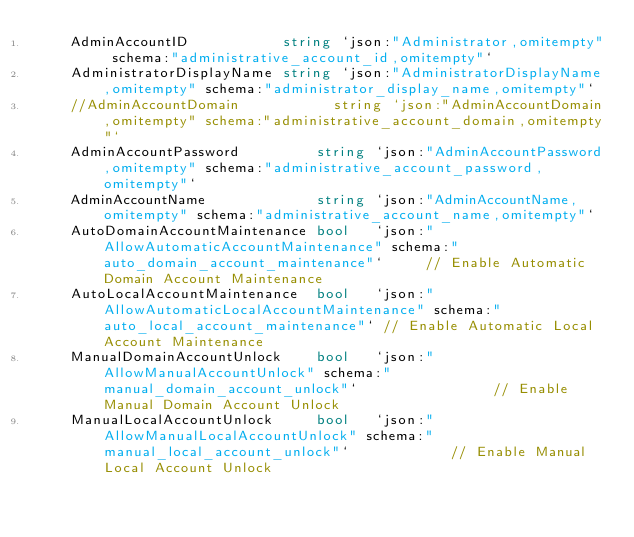Convert code to text. <code><loc_0><loc_0><loc_500><loc_500><_Go_>	AdminAccountID           string `json:"Administrator,omitempty" schema:"administrative_account_id,omitempty"`
	AdministratorDisplayName string `json:"AdministratorDisplayName,omitempty" schema:"administrator_display_name,omitempty"`
	//AdminAccountDomain           string `json:"AdminAccountDomain,omitempty" schema:"administrative_account_domain,omitempty"`
	AdminAccountPassword         string `json:"AdminAccountPassword,omitempty" schema:"administrative_account_password,omitempty"`
	AdminAccountName             string `json:"AdminAccountName,omitempty" schema:"administrative_account_name,omitempty"`
	AutoDomainAccountMaintenance bool   `json:"AllowAutomaticAccountMaintenance" schema:"auto_domain_account_maintenance"`     // Enable Automatic Domain Account Maintenance
	AutoLocalAccountMaintenance  bool   `json:"AllowAutomaticLocalAccountMaintenance" schema:"auto_local_account_maintenance"` // Enable Automatic Local Account Maintenance
	ManualDomainAccountUnlock    bool   `json:"AllowManualAccountUnlock" schema:"manual_domain_account_unlock"`                // Enable Manual Domain Account Unlock
	ManualLocalAccountUnlock     bool   `json:"AllowManualLocalAccountUnlock" schema:"manual_local_account_unlock"`            // Enable Manual Local Account Unlock</code> 